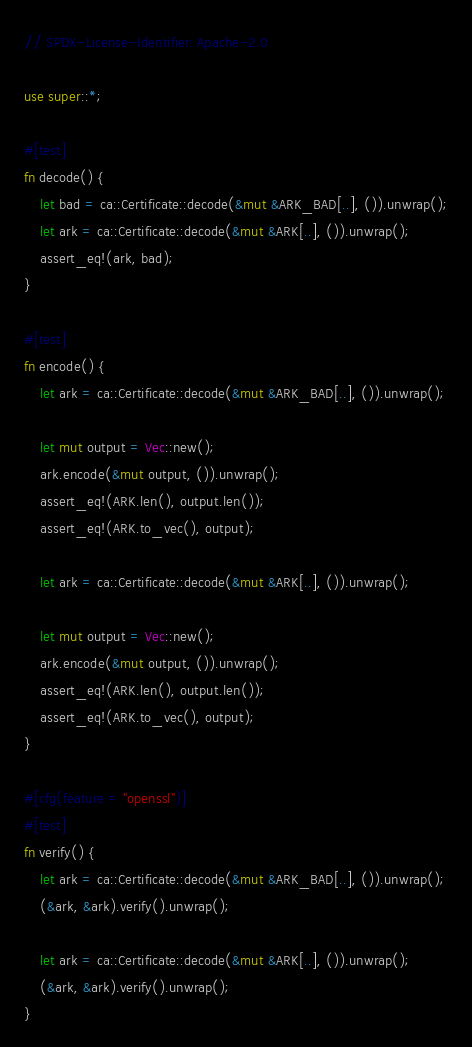Convert code to text. <code><loc_0><loc_0><loc_500><loc_500><_Rust_>// SPDX-License-Identifier: Apache-2.0

use super::*;

#[test]
fn decode() {
    let bad = ca::Certificate::decode(&mut &ARK_BAD[..], ()).unwrap();
    let ark = ca::Certificate::decode(&mut &ARK[..], ()).unwrap();
    assert_eq!(ark, bad);
}

#[test]
fn encode() {
    let ark = ca::Certificate::decode(&mut &ARK_BAD[..], ()).unwrap();

    let mut output = Vec::new();
    ark.encode(&mut output, ()).unwrap();
    assert_eq!(ARK.len(), output.len());
    assert_eq!(ARK.to_vec(), output);

    let ark = ca::Certificate::decode(&mut &ARK[..], ()).unwrap();

    let mut output = Vec::new();
    ark.encode(&mut output, ()).unwrap();
    assert_eq!(ARK.len(), output.len());
    assert_eq!(ARK.to_vec(), output);
}

#[cfg(feature = "openssl")]
#[test]
fn verify() {
    let ark = ca::Certificate::decode(&mut &ARK_BAD[..], ()).unwrap();
    (&ark, &ark).verify().unwrap();

    let ark = ca::Certificate::decode(&mut &ARK[..], ()).unwrap();
    (&ark, &ark).verify().unwrap();
}
</code> 